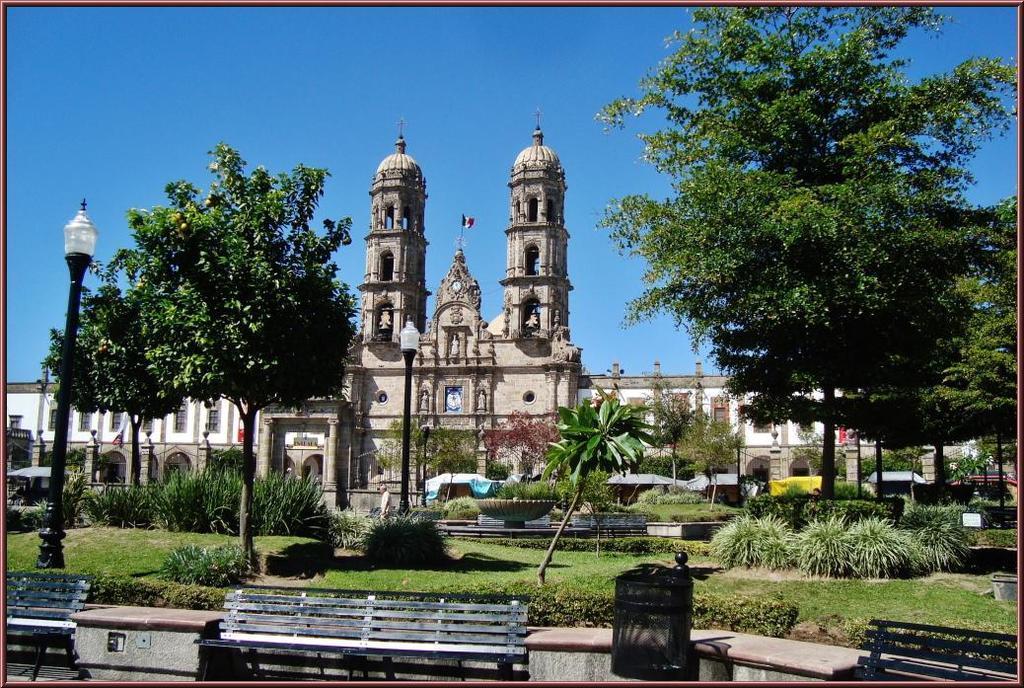Describe this image in one or two sentences. This picture seems to be an edited image with the borders. In the foreground we can see the benches and some other objects. In the center we can see the green grass, plants, trees, lamps attached to the poles and we can see the buildings, towers with the domes and we can see a flag and a clock hanging on the wall of the building. In the background we can see the sky and a person and some objects seems to be the tents and many other objects. 